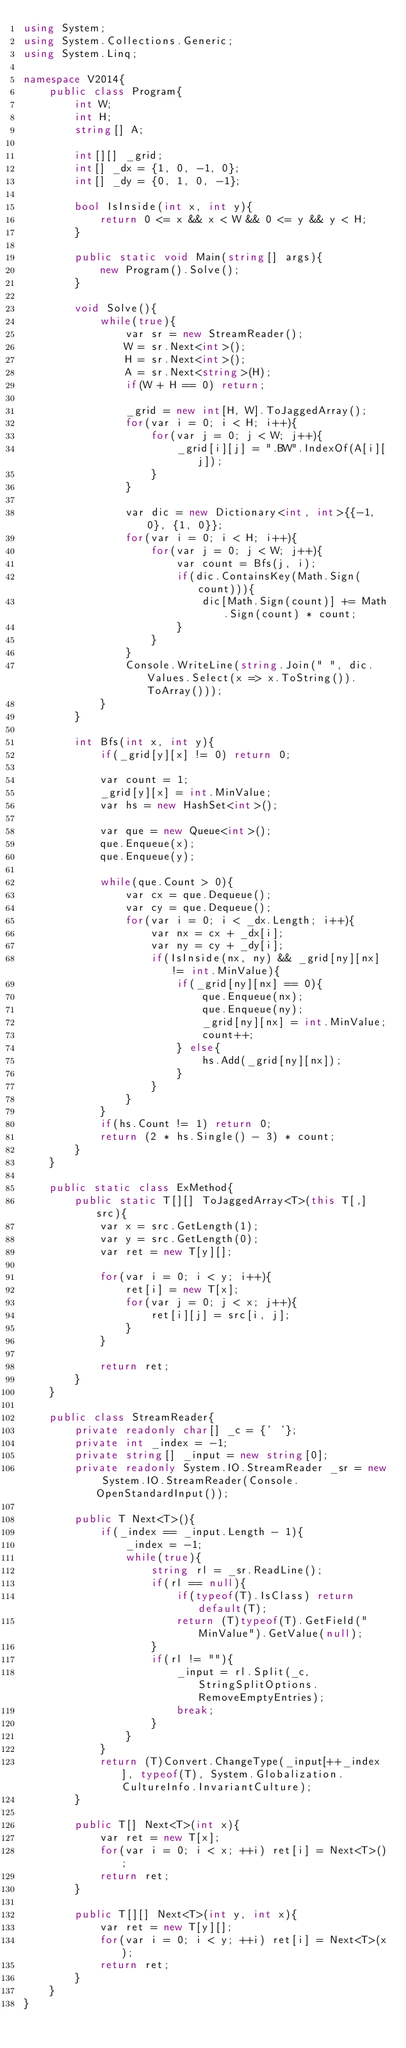Convert code to text. <code><loc_0><loc_0><loc_500><loc_500><_C#_>using System;
using System.Collections.Generic;
using System.Linq;

namespace V2014{
    public class Program{
        int W;
        int H;
        string[] A;

        int[][] _grid;
        int[] _dx = {1, 0, -1, 0};
        int[] _dy = {0, 1, 0, -1};

        bool IsInside(int x, int y){
            return 0 <= x && x < W && 0 <= y && y < H;
        }

        public static void Main(string[] args){
            new Program().Solve();
        }

        void Solve(){
            while(true){
                var sr = new StreamReader();
                W = sr.Next<int>();
                H = sr.Next<int>();
                A = sr.Next<string>(H);
                if(W + H == 0) return;

                _grid = new int[H, W].ToJaggedArray();
                for(var i = 0; i < H; i++){
                    for(var j = 0; j < W; j++){
                        _grid[i][j] = ".BW".IndexOf(A[i][j]);
                    }
                }

                var dic = new Dictionary<int, int>{{-1, 0}, {1, 0}};
                for(var i = 0; i < H; i++){
                    for(var j = 0; j < W; j++){
                        var count = Bfs(j, i);
                        if(dic.ContainsKey(Math.Sign(count))){
                            dic[Math.Sign(count)] += Math.Sign(count) * count;
                        }
                    }
                }
                Console.WriteLine(string.Join(" ", dic.Values.Select(x => x.ToString()).ToArray()));
            }
        }

        int Bfs(int x, int y){
            if(_grid[y][x] != 0) return 0;

            var count = 1;
            _grid[y][x] = int.MinValue;
            var hs = new HashSet<int>();

            var que = new Queue<int>();
            que.Enqueue(x);
            que.Enqueue(y);

            while(que.Count > 0){
                var cx = que.Dequeue();
                var cy = que.Dequeue();
                for(var i = 0; i < _dx.Length; i++){
                    var nx = cx + _dx[i];
                    var ny = cy + _dy[i];
                    if(IsInside(nx, ny) && _grid[ny][nx] != int.MinValue){
                        if(_grid[ny][nx] == 0){
                            que.Enqueue(nx);
                            que.Enqueue(ny);
                            _grid[ny][nx] = int.MinValue;
                            count++;
                        } else{
                            hs.Add(_grid[ny][nx]);
                        }
                    }
                }
            }
            if(hs.Count != 1) return 0;
            return (2 * hs.Single() - 3) * count;
        }
    }

    public static class ExMethod{
        public static T[][] ToJaggedArray<T>(this T[,] src){
            var x = src.GetLength(1);
            var y = src.GetLength(0);
            var ret = new T[y][];

            for(var i = 0; i < y; i++){
                ret[i] = new T[x];
                for(var j = 0; j < x; j++){
                    ret[i][j] = src[i, j];
                }
            }

            return ret;
        }
    }

    public class StreamReader{
        private readonly char[] _c = {' '};
        private int _index = -1;
        private string[] _input = new string[0];
        private readonly System.IO.StreamReader _sr = new System.IO.StreamReader(Console.OpenStandardInput());

        public T Next<T>(){
            if(_index == _input.Length - 1){
                _index = -1;
                while(true){
                    string rl = _sr.ReadLine();
                    if(rl == null){
                        if(typeof(T).IsClass) return default(T);
                        return (T)typeof(T).GetField("MinValue").GetValue(null);
                    }
                    if(rl != ""){
                        _input = rl.Split(_c, StringSplitOptions.RemoveEmptyEntries);
                        break;
                    }
                }
            }
            return (T)Convert.ChangeType(_input[++_index], typeof(T), System.Globalization.CultureInfo.InvariantCulture);
        }

        public T[] Next<T>(int x){
            var ret = new T[x];
            for(var i = 0; i < x; ++i) ret[i] = Next<T>();
            return ret;
        }

        public T[][] Next<T>(int y, int x){
            var ret = new T[y][];
            for(var i = 0; i < y; ++i) ret[i] = Next<T>(x);
            return ret;
        }
    }
}</code> 